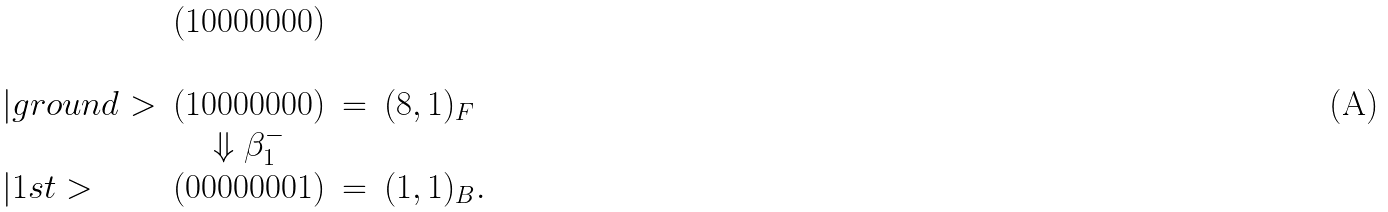<formula> <loc_0><loc_0><loc_500><loc_500>\begin{array} { l c c l } & ( 1 0 0 0 0 0 0 0 ) \\ \\ | g r o u n d > & ( 1 0 0 0 0 0 0 0 ) & = & ( { 8 } , { 1 } ) _ { F } \\ & \Downarrow \beta _ { 1 } ^ { - } \\ | 1 s t > & ( 0 0 0 0 0 0 0 1 ) & = & ( { 1 } , { 1 } ) _ { B } . \\ \end{array}</formula> 